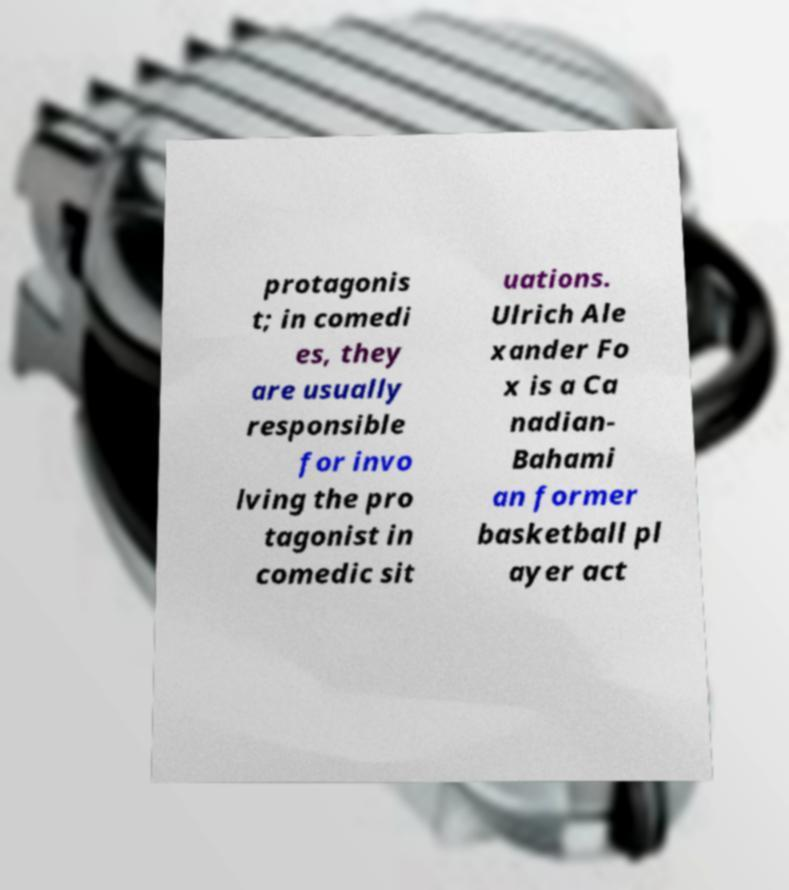Could you assist in decoding the text presented in this image and type it out clearly? protagonis t; in comedi es, they are usually responsible for invo lving the pro tagonist in comedic sit uations. Ulrich Ale xander Fo x is a Ca nadian- Bahami an former basketball pl ayer act 